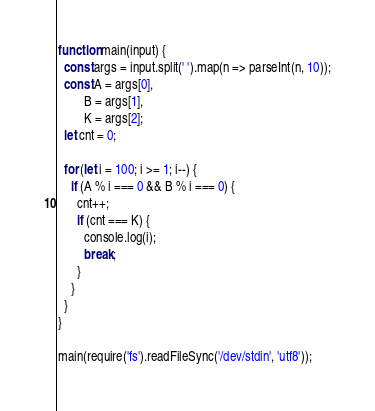Convert code to text. <code><loc_0><loc_0><loc_500><loc_500><_JavaScript_>function main(input) {
  const args = input.split(' ').map(n => parseInt(n, 10));
  const A = args[0],
        B = args[1],
        K = args[2];
  let cnt = 0;
  
  for (let i = 100; i >= 1; i--) {
    if (A % i === 0 && B % i === 0) {
      cnt++;
      if (cnt === K) {
        console.log(i);
        break;
      }
    }
  }
}

main(require('fs').readFileSync('/dev/stdin', 'utf8'));</code> 